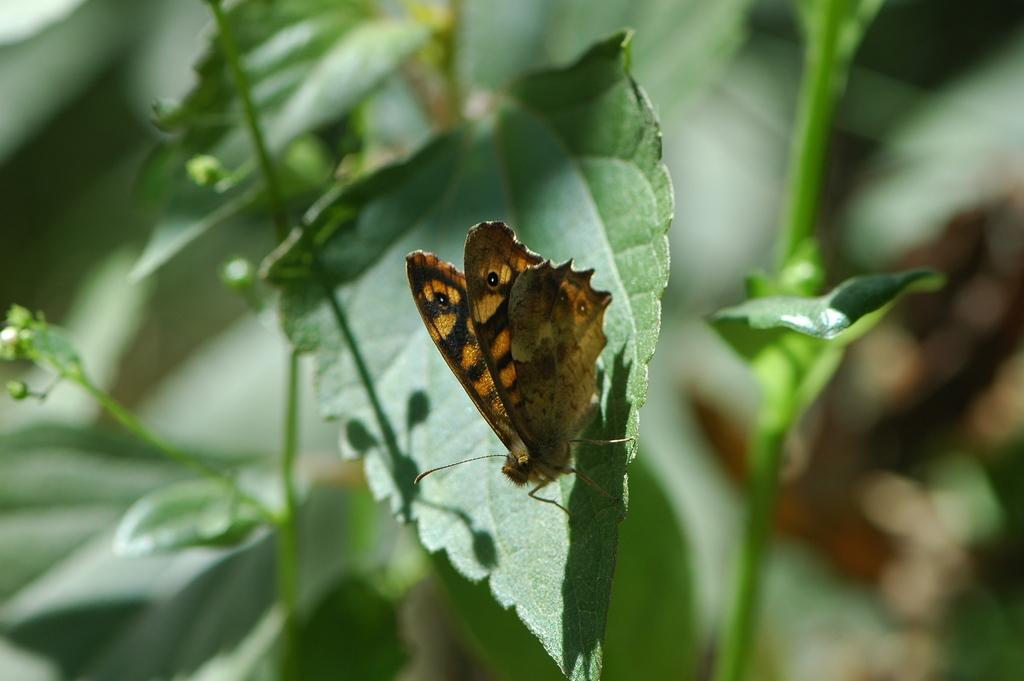What type of vegetation is present in the image? There are green-colored leaves in the image. What other living organism can be seen in the image? There is a brown-colored insect in the image. How would you describe the overall clarity of the image? The image is blurry in the background. What type of flesh can be seen on the leaves in the image? There is no flesh present on the leaves in the image; they are green-colored vegetation. How many beads are visible on the insect in the image? There are no beads present on the insect in the image; it is a brown-colored insect without any visible beads. 